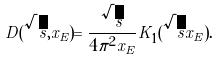Convert formula to latex. <formula><loc_0><loc_0><loc_500><loc_500>D ( \sqrt { s } , x _ { E } ) = \frac { \sqrt { s } } { 4 \pi ^ { 2 } x _ { E } } K _ { 1 } ( \sqrt { s } x _ { E } ) .</formula> 